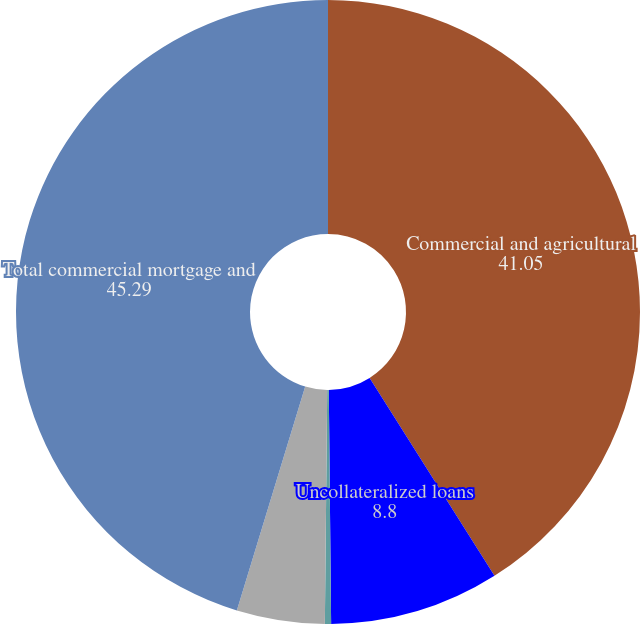<chart> <loc_0><loc_0><loc_500><loc_500><pie_chart><fcel>Commercial and agricultural<fcel>Uncollateralized loans<fcel>Residential property loans<fcel>Other collateralized loans<fcel>Total commercial mortgage and<nl><fcel>41.05%<fcel>8.8%<fcel>0.32%<fcel>4.56%<fcel>45.29%<nl></chart> 